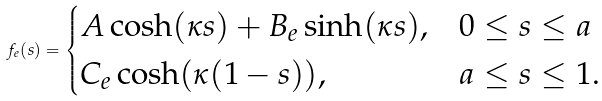Convert formula to latex. <formula><loc_0><loc_0><loc_500><loc_500>f _ { e } ( s ) = \begin{cases} A \cosh ( \kappa s ) + B _ { e } \sinh ( \kappa s ) , & 0 \leq s \leq a \\ C _ { e } \cosh ( \kappa ( 1 - s ) ) , & a \leq s \leq 1 . \end{cases}</formula> 